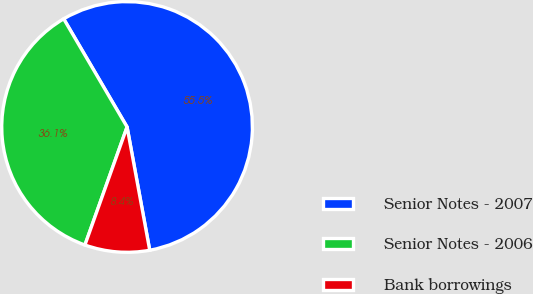Convert chart. <chart><loc_0><loc_0><loc_500><loc_500><pie_chart><fcel>Senior Notes - 2007<fcel>Senior Notes - 2006<fcel>Bank borrowings<nl><fcel>55.54%<fcel>36.1%<fcel>8.35%<nl></chart> 